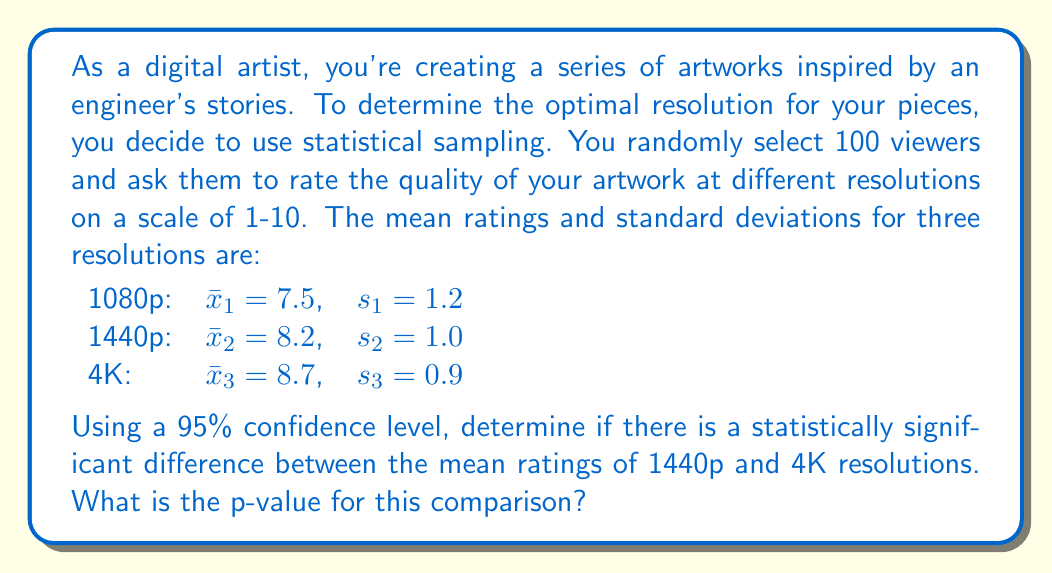Help me with this question. To determine if there's a statistically significant difference between the mean ratings of 1440p and 4K resolutions, we'll use a two-sample t-test. Here are the steps:

1. Calculate the pooled standard error:
   $$SE = \sqrt{\frac{s_1^2}{n_1} + \frac{s_2^2}{n_2}}$$
   Where $n_1 = n_2 = 100$ (sample size for each group)
   $$SE = \sqrt{\frac{1.0^2}{100} + \frac{0.9^2}{100}} = \sqrt{0.01 + 0.0081} = \sqrt{0.0181} = 0.1345$$

2. Calculate the t-statistic:
   $$t = \frac{\bar{x}_2 - \bar{x}_3}{SE} = \frac{8.2 - 8.7}{0.1345} = -3.717$$

3. Degrees of freedom:
   $df = n_1 + n_2 - 2 = 100 + 100 - 2 = 198$

4. Find the p-value:
   For a two-tailed test at 95% confidence level, we need to find P(|t| > 3.717) with 198 degrees of freedom.
   Using a t-distribution table or calculator, we find:
   p-value ≈ 0.0002604

5. Interpret the result:
   Since the p-value (0.0002604) is less than the significance level (0.05), we reject the null hypothesis. This means there is a statistically significant difference between the mean ratings of 1440p and 4K resolutions.
Answer: p-value ≈ 0.0002604 